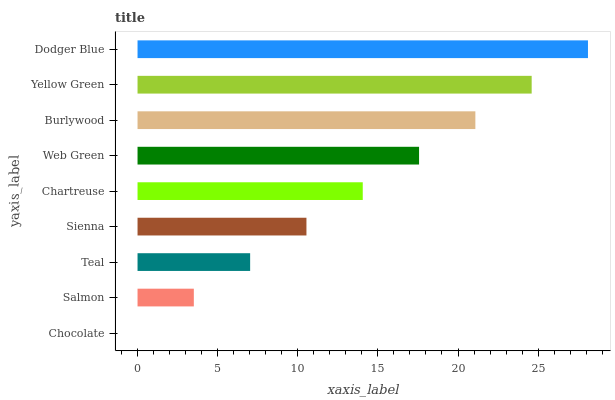Is Chocolate the minimum?
Answer yes or no. Yes. Is Dodger Blue the maximum?
Answer yes or no. Yes. Is Salmon the minimum?
Answer yes or no. No. Is Salmon the maximum?
Answer yes or no. No. Is Salmon greater than Chocolate?
Answer yes or no. Yes. Is Chocolate less than Salmon?
Answer yes or no. Yes. Is Chocolate greater than Salmon?
Answer yes or no. No. Is Salmon less than Chocolate?
Answer yes or no. No. Is Chartreuse the high median?
Answer yes or no. Yes. Is Chartreuse the low median?
Answer yes or no. Yes. Is Salmon the high median?
Answer yes or no. No. Is Dodger Blue the low median?
Answer yes or no. No. 